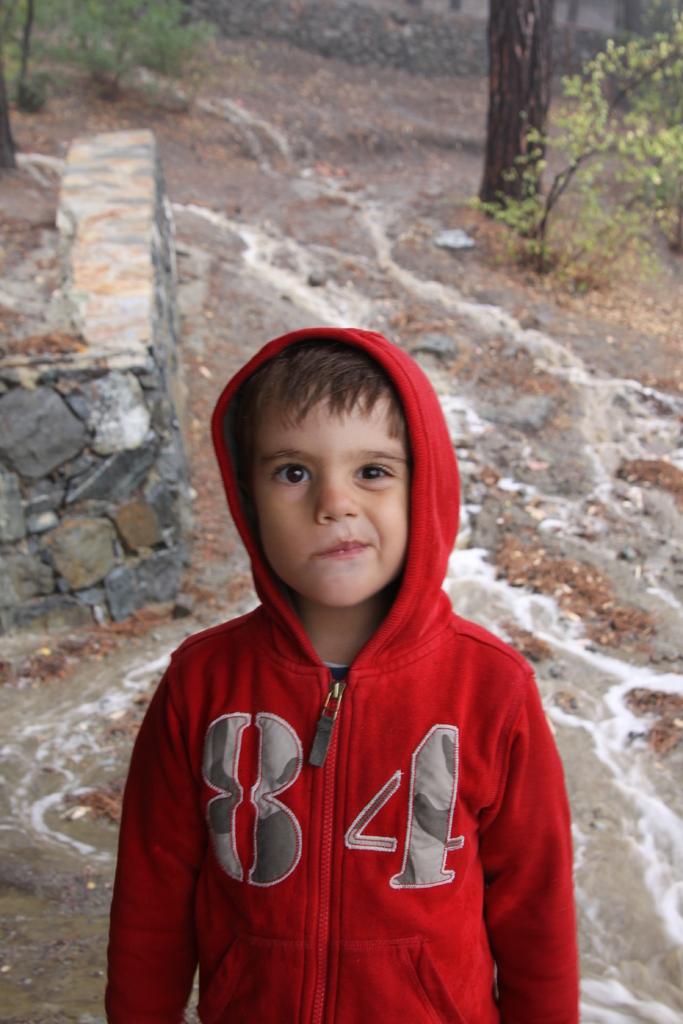What number is on the kid's hoodie?
Keep it short and to the point. 84. 